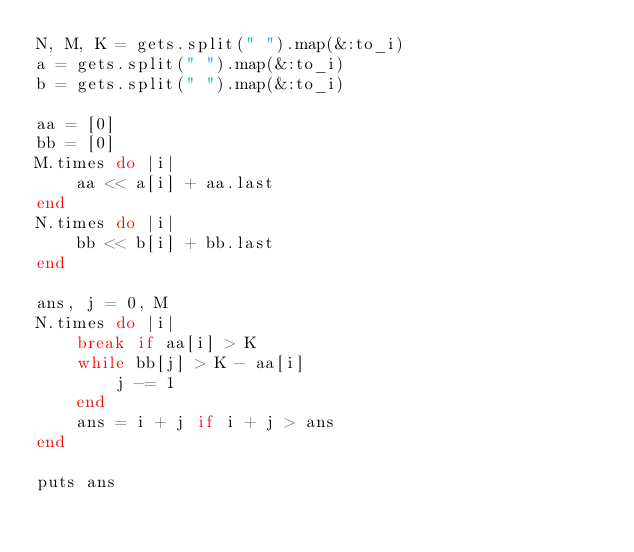Convert code to text. <code><loc_0><loc_0><loc_500><loc_500><_Ruby_>N, M, K = gets.split(" ").map(&:to_i)
a = gets.split(" ").map(&:to_i)
b = gets.split(" ").map(&:to_i)

aa = [0]
bb = [0]
M.times do |i|
    aa << a[i] + aa.last
end
N.times do |i|
    bb << b[i] + bb.last
end

ans, j = 0, M
N.times do |i|
    break if aa[i] > K
    while bb[j] > K - aa[i]
        j -= 1
    end
    ans = i + j if i + j > ans
end

puts ans</code> 